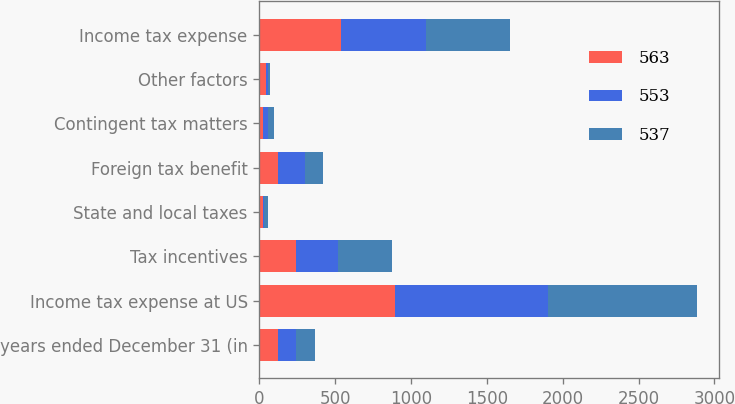Convert chart. <chart><loc_0><loc_0><loc_500><loc_500><stacked_bar_chart><ecel><fcel>years ended December 31 (in<fcel>Income tax expense at US<fcel>Tax incentives<fcel>State and local taxes<fcel>Foreign tax benefit<fcel>Contingent tax matters<fcel>Other factors<fcel>Income tax expense<nl><fcel>563<fcel>122<fcel>892<fcel>240<fcel>22<fcel>122<fcel>26<fcel>41<fcel>537<nl><fcel>553<fcel>122<fcel>1011<fcel>277<fcel>11<fcel>177<fcel>30<fcel>13<fcel>563<nl><fcel>537<fcel>122<fcel>983<fcel>360<fcel>25<fcel>118<fcel>39<fcel>16<fcel>553<nl></chart> 